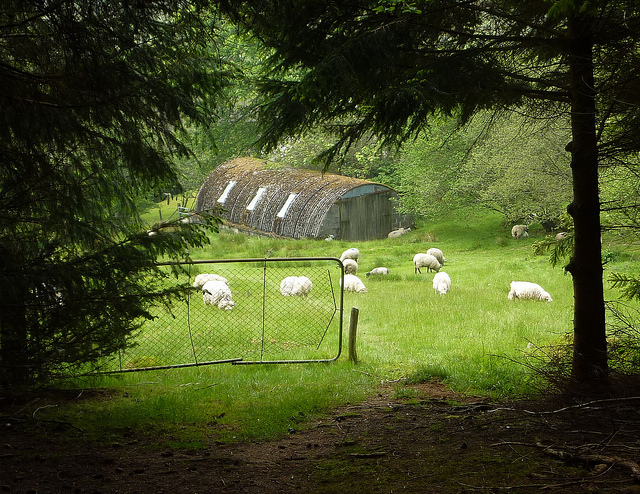<image>What is the roof made of? I am not sure what the roof is made of. It could be metal, hay, net, thatch, or tin. What is the roof made of? It is not sure what the roof is made of. It is difficult to tell from the image, but it can be seen metal. 